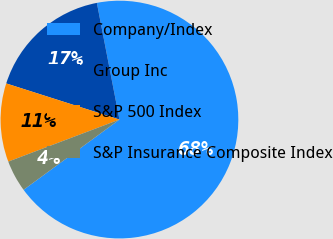Convert chart. <chart><loc_0><loc_0><loc_500><loc_500><pie_chart><fcel>Company/Index<fcel>Group Inc<fcel>S&P 500 Index<fcel>S&P Insurance Composite Index<nl><fcel>67.98%<fcel>17.04%<fcel>10.67%<fcel>4.31%<nl></chart> 